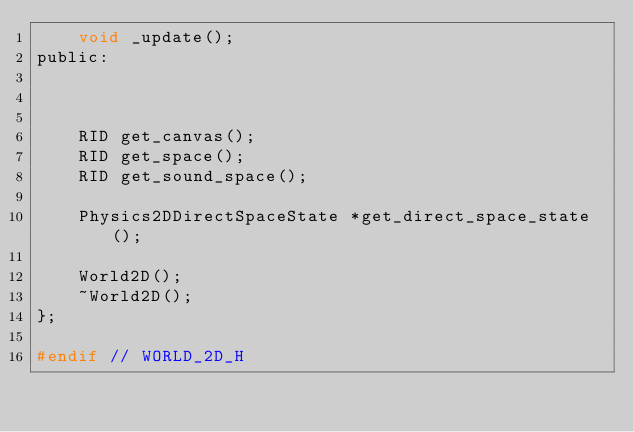<code> <loc_0><loc_0><loc_500><loc_500><_C_>	void _update();
public:



	RID get_canvas();
	RID get_space();
	RID get_sound_space();

	Physics2DDirectSpaceState *get_direct_space_state();

	World2D();
	~World2D();
};

#endif // WORLD_2D_H
</code> 